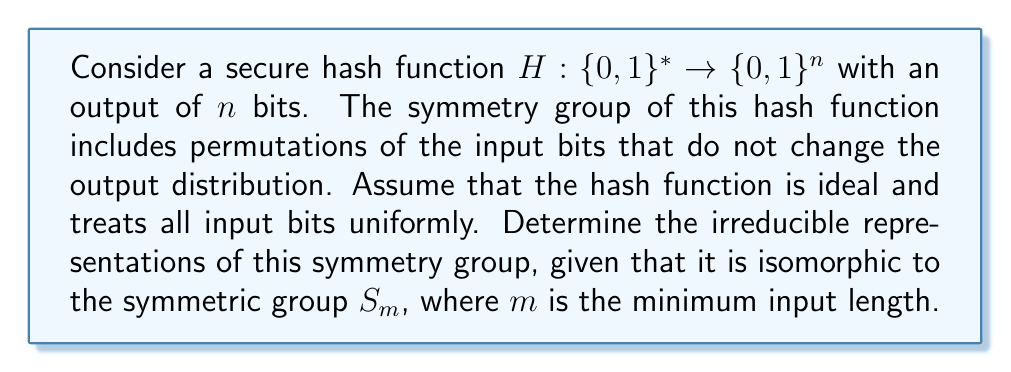What is the answer to this math problem? 1. Identify the symmetry group:
   The symmetry group of the hash function is isomorphic to $S_m$, the symmetric group on $m$ elements.

2. Recall the irreducible representations of $S_m$:
   The irreducible representations of $S_m$ are in one-to-one correspondence with partitions of $m$.

3. List the partitions of $m$:
   The partitions of $m$ are all the ways to write $m$ as a sum of positive integers, where the order doesn't matter.

4. Young diagrams:
   Each partition corresponds to a Young diagram, which visually represents the irreducible representation.

5. Dimensions of irreducible representations:
   The dimension of each irreducible representation can be calculated using the hook length formula:

   $$\dim(\lambda) = \frac{m!}{\prod_{(i,j)\in\lambda} h_{ij}}$$

   where $\lambda$ is the partition, and $h_{ij}$ is the hook length of the cell $(i,j)$ in the Young diagram.

6. Character table:
   The full character table of $S_m$ can be constructed using the Murnaghan-Nakayama rule or other methods.

7. Interpretation for the hash function:
   Each irreducible representation corresponds to a way the hash function's symmetry can be decomposed into fundamental transformations that cannot be further simplified.
Answer: The irreducible representations of the hash function's symmetry group are in one-to-one correspondence with the partitions of $m$, where $m$ is the minimum input length, with dimensions given by the hook length formula. 